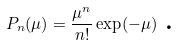Convert formula to latex. <formula><loc_0><loc_0><loc_500><loc_500>P _ { n } ( \mu ) = \frac { \mu ^ { n } } { n ! } \exp ( - \mu ) \text { .}</formula> 